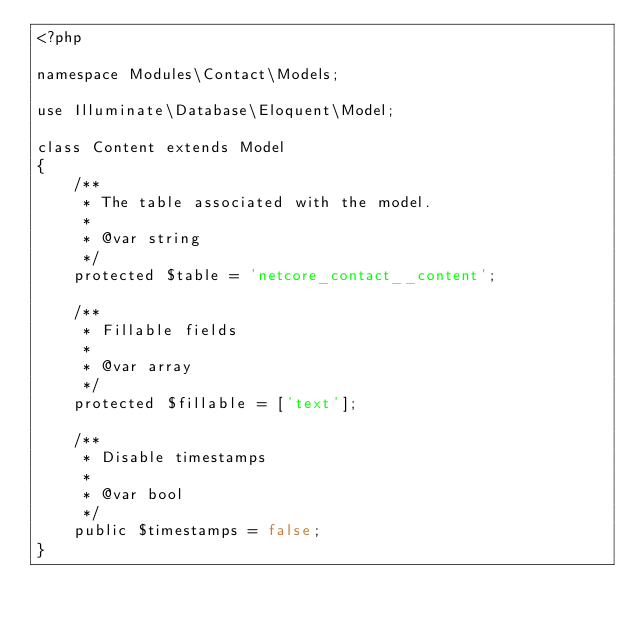Convert code to text. <code><loc_0><loc_0><loc_500><loc_500><_PHP_><?php

namespace Modules\Contact\Models;

use Illuminate\Database\Eloquent\Model;

class Content extends Model
{
    /**
     * The table associated with the model.
     *
     * @var string
     */
    protected $table = 'netcore_contact__content';

    /**
     * Fillable fields
     *
     * @var array
     */
    protected $fillable = ['text'];

    /**
     * Disable timestamps
     *
     * @var bool
     */
    public $timestamps = false;
}
</code> 